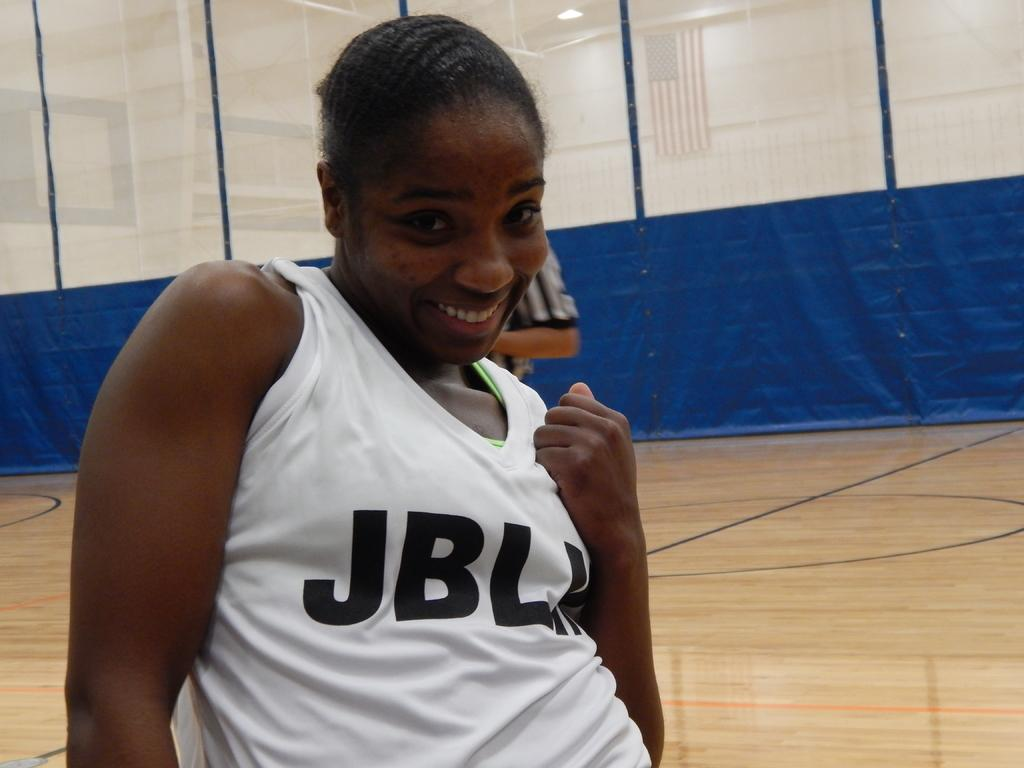<image>
Write a terse but informative summary of the picture. A girl stands on an indoor court, her shirt reads JBL and one other letter is hidden. 